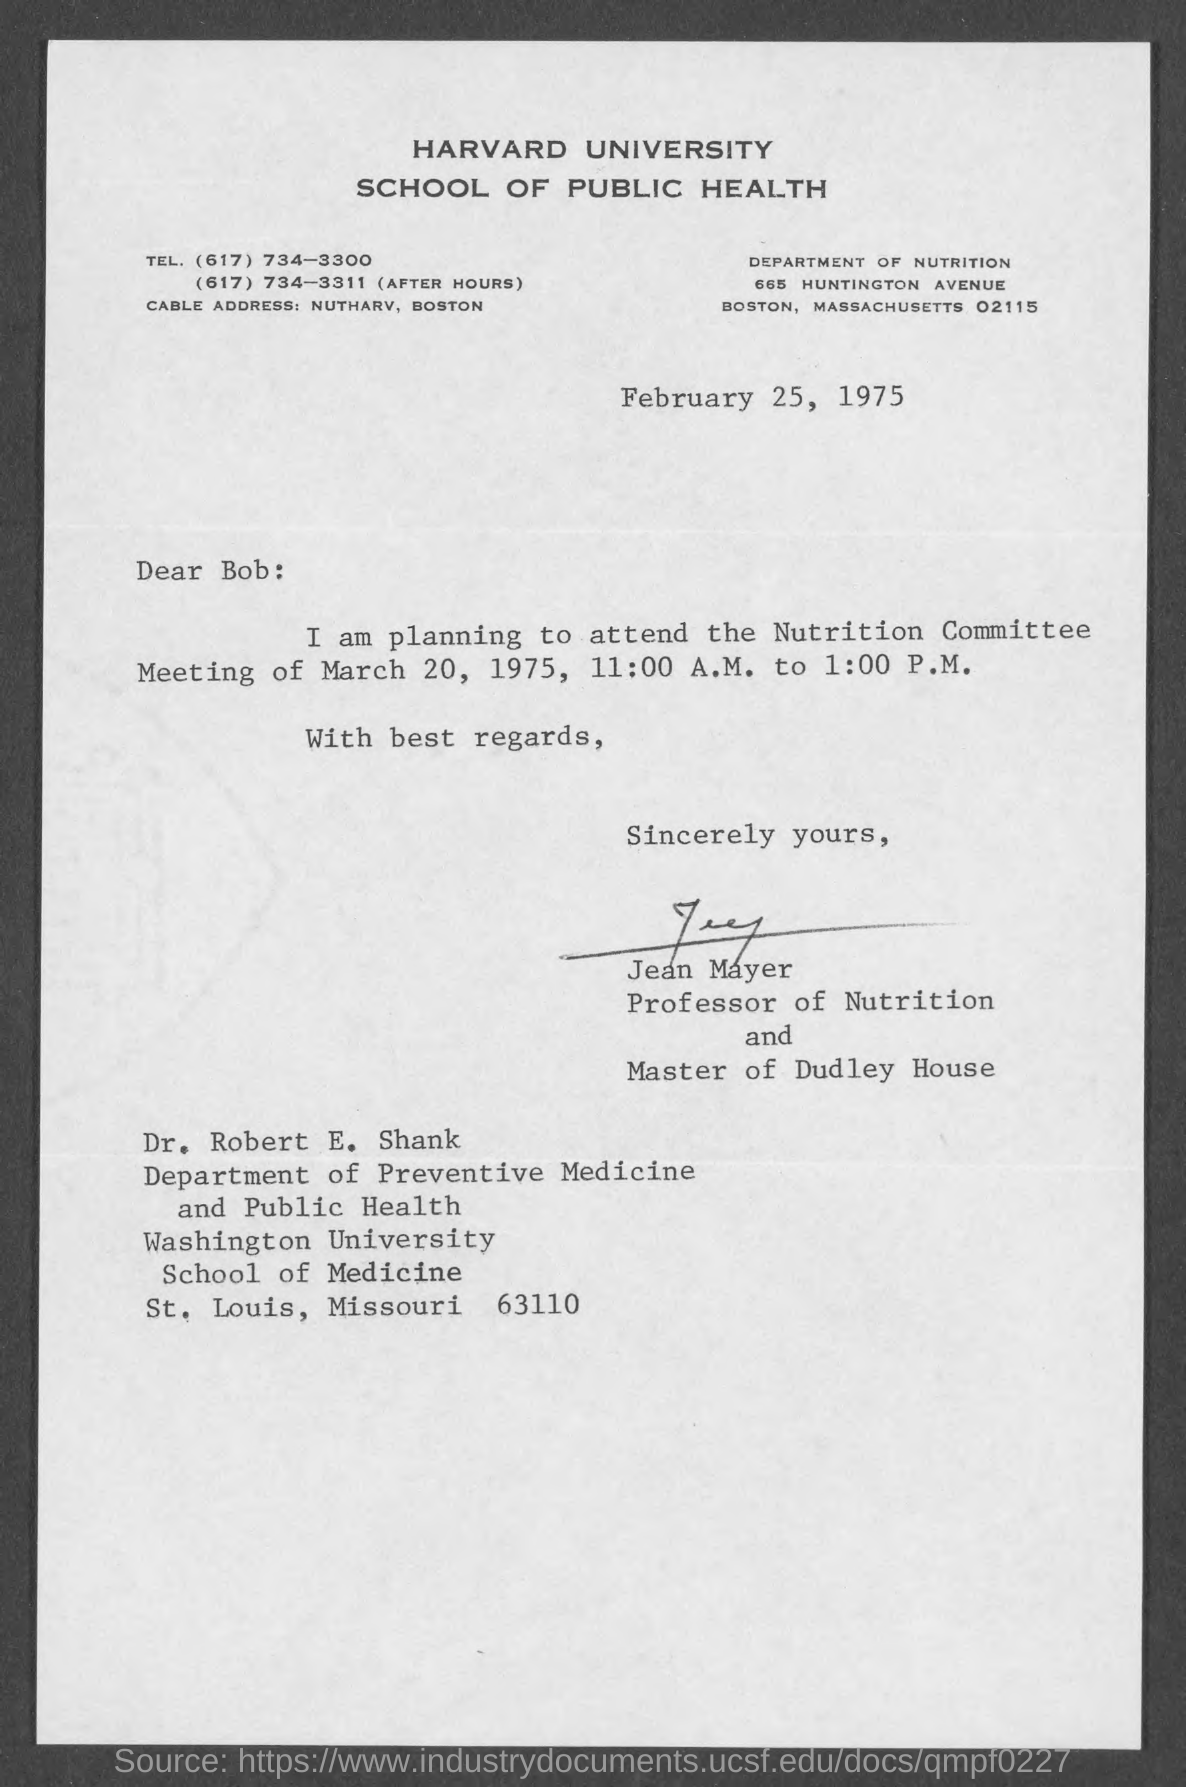What is written in the Letter Head ?
Give a very brief answer. HARVARD UNIVERSITY SCHOOL OF PUBLIC HEALTH. What is the Date mentioned in the top of the document ?
Give a very brief answer. February 25, 1975. Who is the Professor of Nutrition ?
Provide a short and direct response. Jean Mayer. 